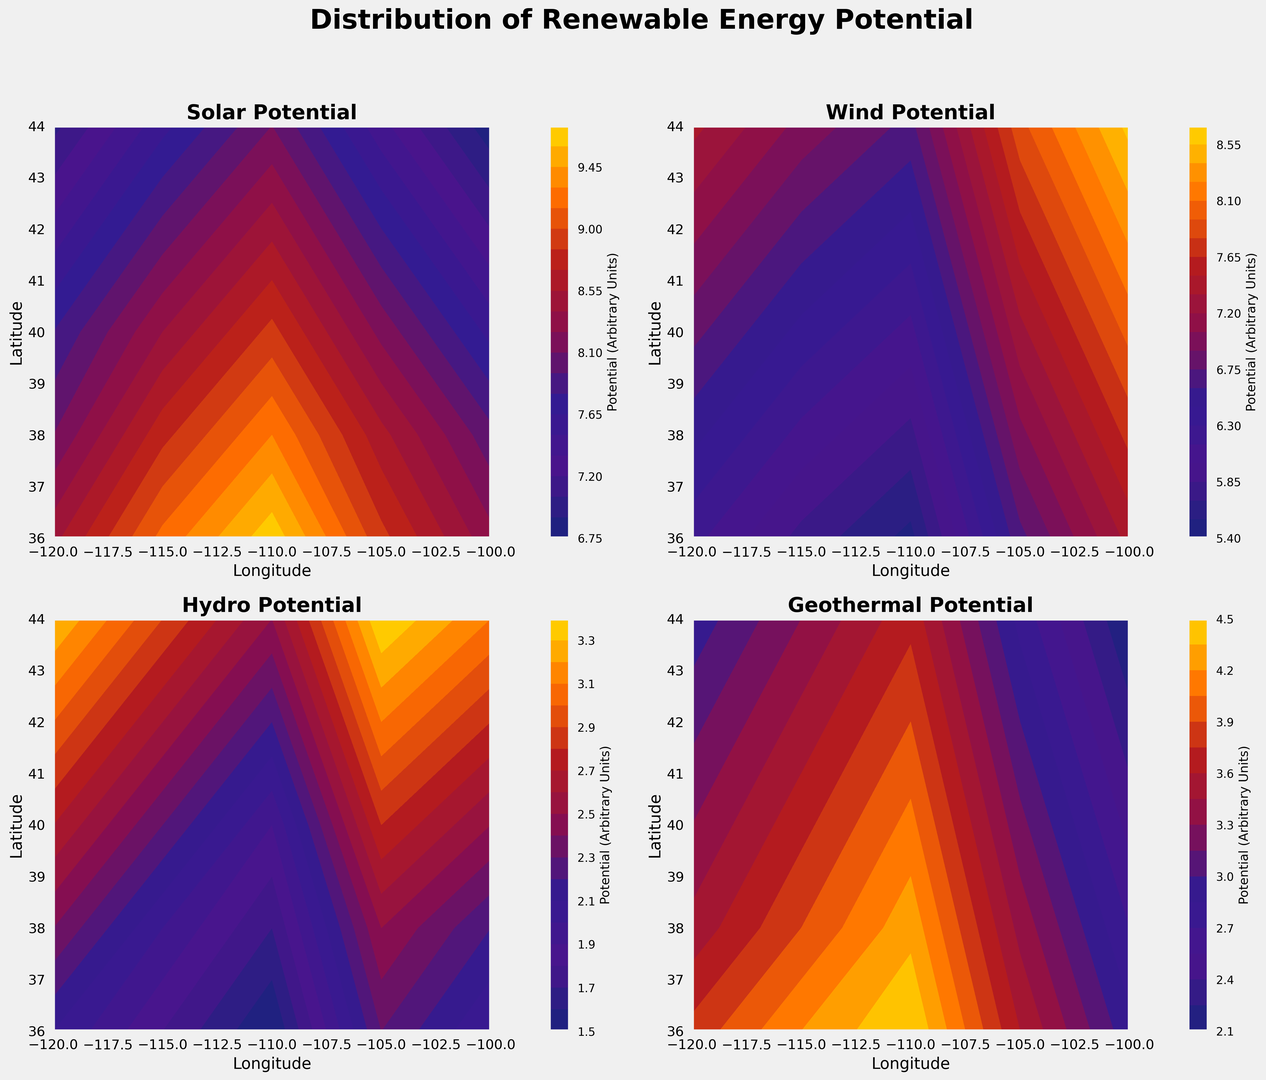Which geographical area exhibits the highest solar potential? By looking at the contour plot for Solar Potential, identify the area where the highest value is depicted using the color coding provided. The area around Latitude 36.0 and Longitude -110.0 has the darkest hue corresponding to the highest value.
Answer: Latitude 36.0, Longitude -110.0 How does wind potential in regions around latitude 40° compare to those around latitude 38°? Refer to the Wind Potential contour plots. For latitude 40°, wind potential ranges from 6.1 to 8.0. For latitude 38°, it ranges from 5.8 to 7.7. The potential is generally higher for regions around latitude 40°.
Answer: Latitude 40° generally higher What's the average Hydro Potential value across all geographical areas shown? Calculate the average of the Hydro Potential values given in the dataset. (2.1 + 1.8 + 1.5 + 2.3 + 2.0 + 2.4 + 2.0 + 1.7 + 2.5 + 2.2 + 2.7 + 2.3 + 1.9 + 2.8 + 2.5 + 3.0 + 2.6 + 2.2 + 3.1 + 2.8 + 3.3 + 2.9 + 2.5 + 3.4 + 3.1) / 25 = 2.44
Answer: 2.44 Which type of renewable energy has the least variability in potential across all geographical areas? Examine the contour plots for Solar, Wind, Hydro, and Geothermal potentials. Hydro Potential curves appear more uniform and less varied in contrast to other charts, indicating lesser variability across geographical areas.
Answer: Hydro Potential What is the range of Geothermal Potential across the dataset? Identify the minimum and maximum values from the Geothermal Potential data in the dataset. The minimum value is 2.1, and the maximum value is 4.5. Hence, the range is 4.5 - 2.1 = 2.4
Answer: 2.4 Is there a correlation between Solar Potential and Wind Potential for the same geographical areas? Refer to corresponding values in Solar Potential and Wind Potential plots for each geographical area. To simplify this, observe areas with higher Solar Potential to see if their Wind Potential also tends to be higher. Generally, high solar regions do not always coincide with high wind regions, suggesting no clear strong correlation.
Answer: No clear strong correlation 